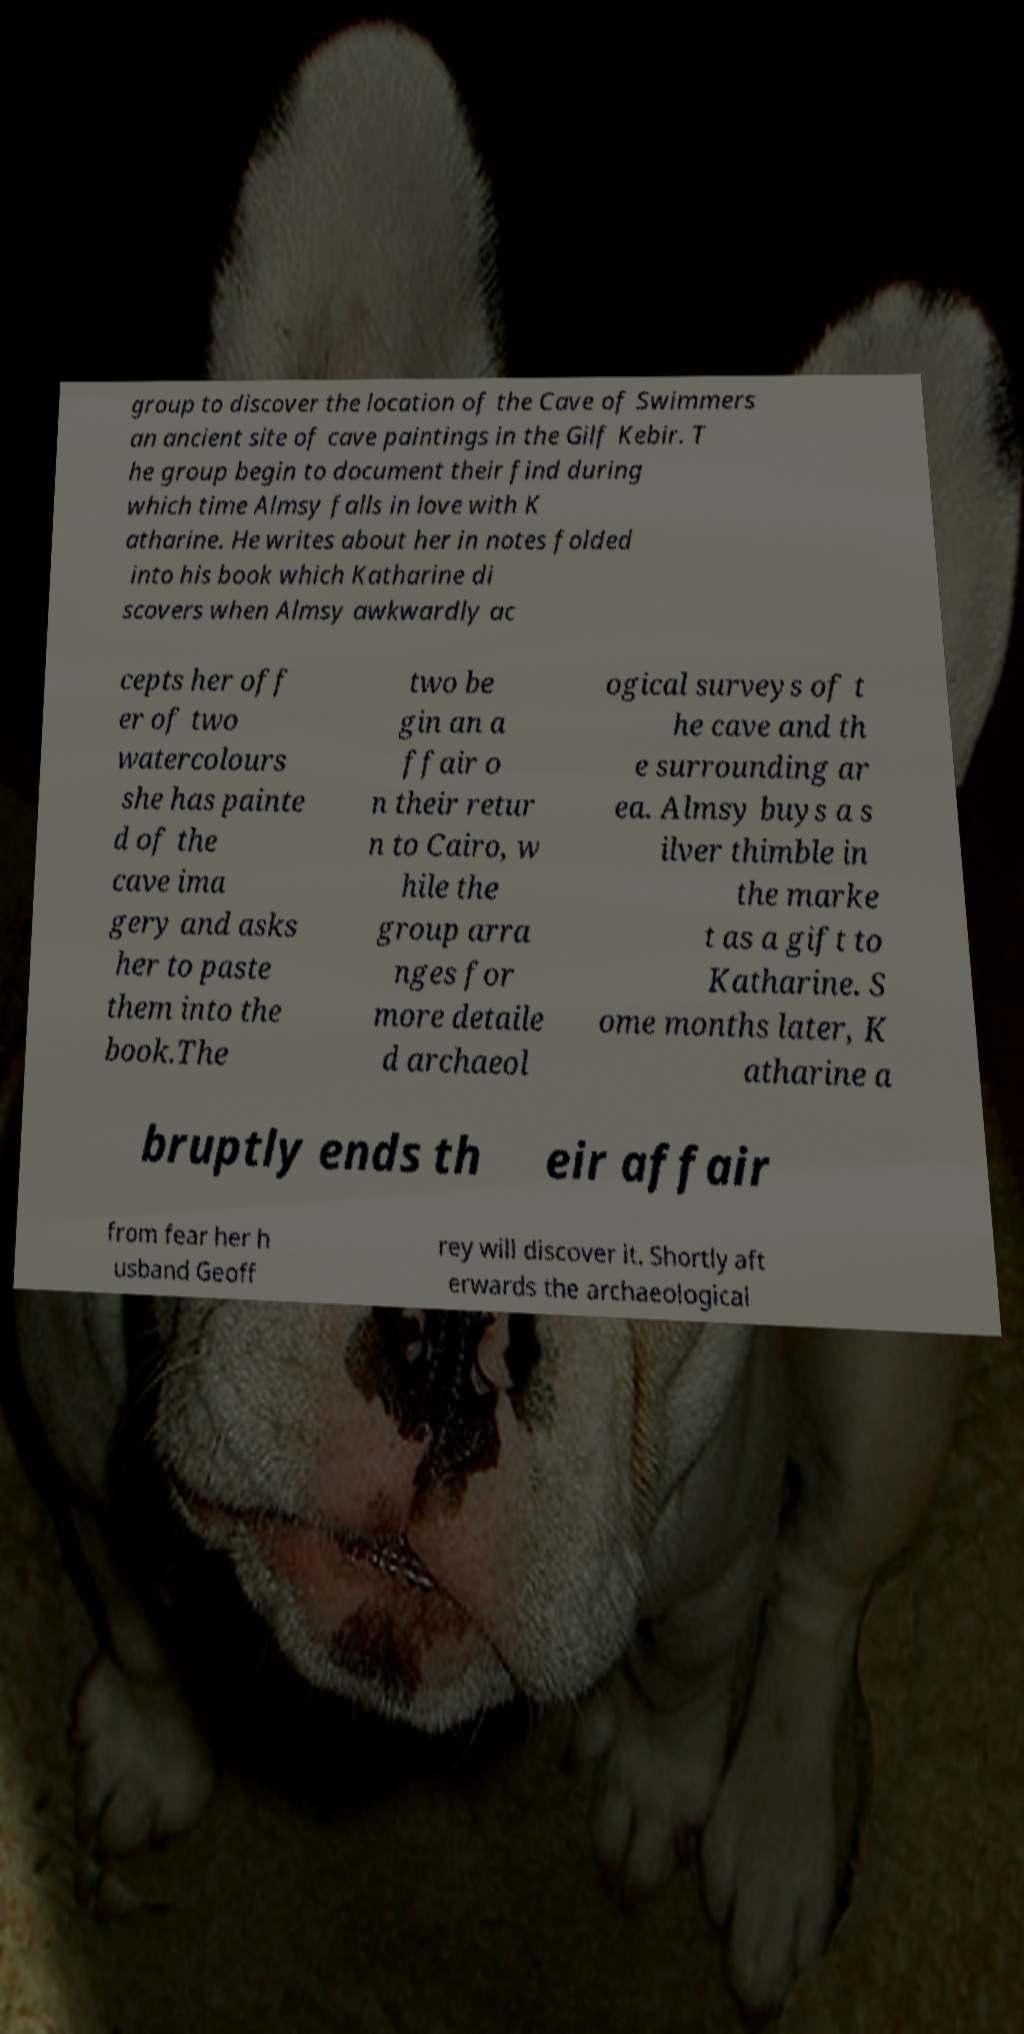There's text embedded in this image that I need extracted. Can you transcribe it verbatim? group to discover the location of the Cave of Swimmers an ancient site of cave paintings in the Gilf Kebir. T he group begin to document their find during which time Almsy falls in love with K atharine. He writes about her in notes folded into his book which Katharine di scovers when Almsy awkwardly ac cepts her off er of two watercolours she has painte d of the cave ima gery and asks her to paste them into the book.The two be gin an a ffair o n their retur n to Cairo, w hile the group arra nges for more detaile d archaeol ogical surveys of t he cave and th e surrounding ar ea. Almsy buys a s ilver thimble in the marke t as a gift to Katharine. S ome months later, K atharine a bruptly ends th eir affair from fear her h usband Geoff rey will discover it. Shortly aft erwards the archaeological 